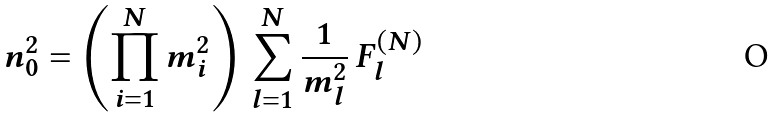<formula> <loc_0><loc_0><loc_500><loc_500>n _ { 0 } ^ { 2 } = \left ( \prod _ { i = 1 } ^ { N } m _ { i } ^ { 2 } \right ) \, \sum _ { l = 1 } ^ { N } \frac { 1 } { m _ { l } ^ { 2 } } \, F _ { l } ^ { ( N ) }</formula> 